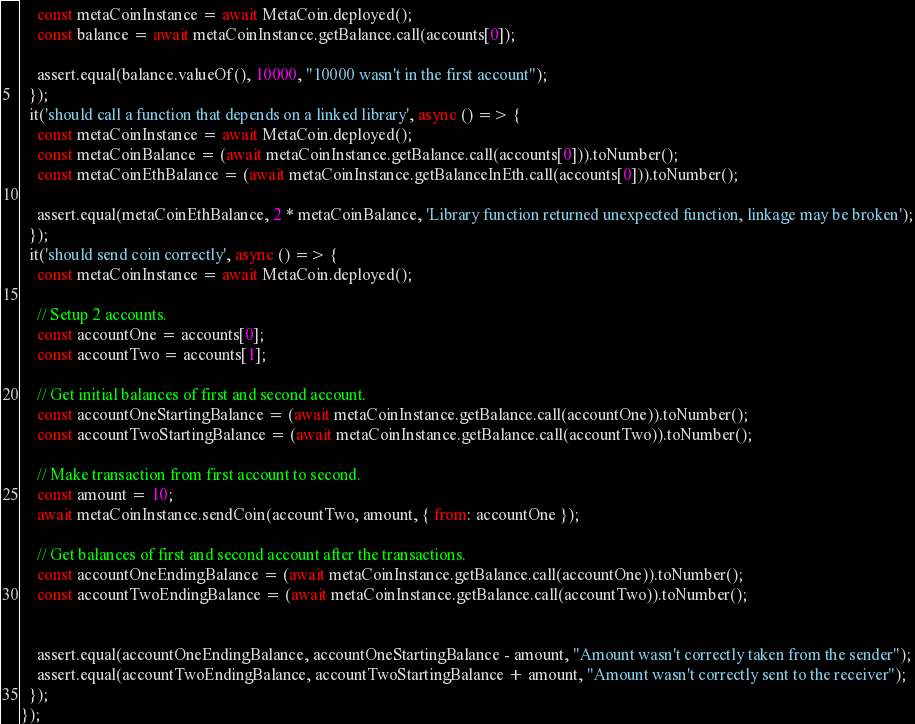<code> <loc_0><loc_0><loc_500><loc_500><_JavaScript_>    const metaCoinInstance = await MetaCoin.deployed();
    const balance = await metaCoinInstance.getBalance.call(accounts[0]);

    assert.equal(balance.valueOf(), 10000, "10000 wasn't in the first account");
  });
  it('should call a function that depends on a linked library', async () => {
    const metaCoinInstance = await MetaCoin.deployed();
    const metaCoinBalance = (await metaCoinInstance.getBalance.call(accounts[0])).toNumber();
    const metaCoinEthBalance = (await metaCoinInstance.getBalanceInEth.call(accounts[0])).toNumber();

    assert.equal(metaCoinEthBalance, 2 * metaCoinBalance, 'Library function returned unexpected function, linkage may be broken');
  });
  it('should send coin correctly', async () => {
    const metaCoinInstance = await MetaCoin.deployed();

    // Setup 2 accounts.
    const accountOne = accounts[0];
    const accountTwo = accounts[1];

    // Get initial balances of first and second account.
    const accountOneStartingBalance = (await metaCoinInstance.getBalance.call(accountOne)).toNumber();
    const accountTwoStartingBalance = (await metaCoinInstance.getBalance.call(accountTwo)).toNumber();

    // Make transaction from first account to second.
    const amount = 10;
    await metaCoinInstance.sendCoin(accountTwo, amount, { from: accountOne });

    // Get balances of first and second account after the transactions.
    const accountOneEndingBalance = (await metaCoinInstance.getBalance.call(accountOne)).toNumber();
    const accountTwoEndingBalance = (await metaCoinInstance.getBalance.call(accountTwo)).toNumber();


    assert.equal(accountOneEndingBalance, accountOneStartingBalance - amount, "Amount wasn't correctly taken from the sender");
    assert.equal(accountTwoEndingBalance, accountTwoStartingBalance + amount, "Amount wasn't correctly sent to the receiver");
  });
});
</code> 